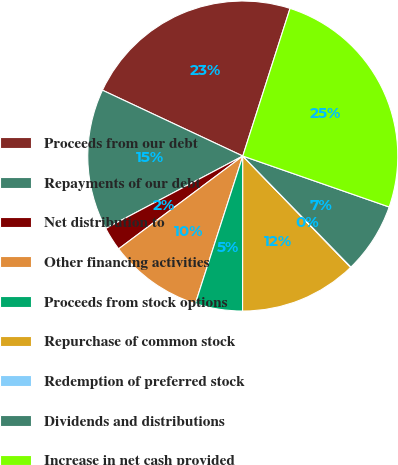Convert chart to OTSL. <chart><loc_0><loc_0><loc_500><loc_500><pie_chart><fcel>Proceeds from our debt<fcel>Repayments of our debt<fcel>Net distribution to<fcel>Other financing activities<fcel>Proceeds from stock options<fcel>Repurchase of common stock<fcel>Redemption of preferred stock<fcel>Dividends and distributions<fcel>Increase in net cash provided<nl><fcel>22.95%<fcel>14.72%<fcel>2.48%<fcel>9.83%<fcel>4.93%<fcel>12.27%<fcel>0.04%<fcel>7.38%<fcel>25.4%<nl></chart> 